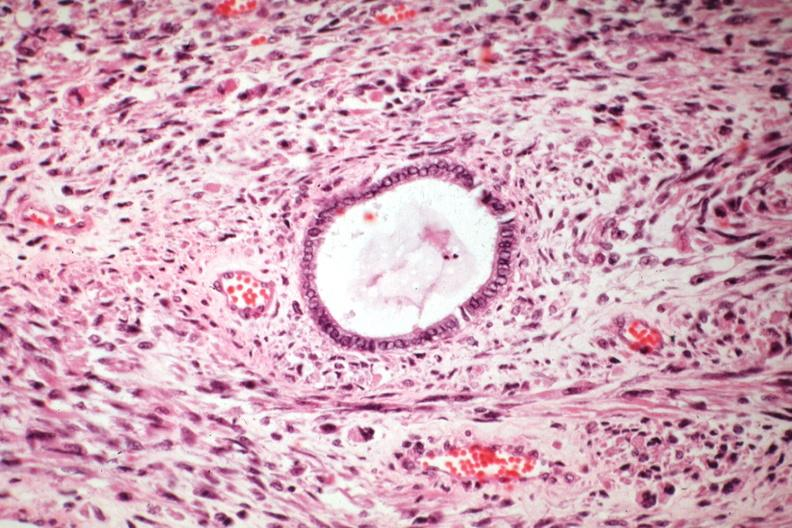s female reproductive present?
Answer the question using a single word or phrase. Yes 